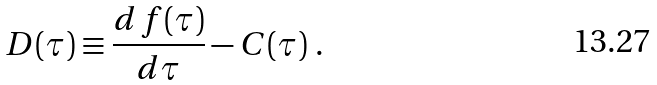Convert formula to latex. <formula><loc_0><loc_0><loc_500><loc_500>D ( \tau ) \equiv \frac { d \, f ( \tau ) } { d \tau } - C ( \tau ) \ .</formula> 